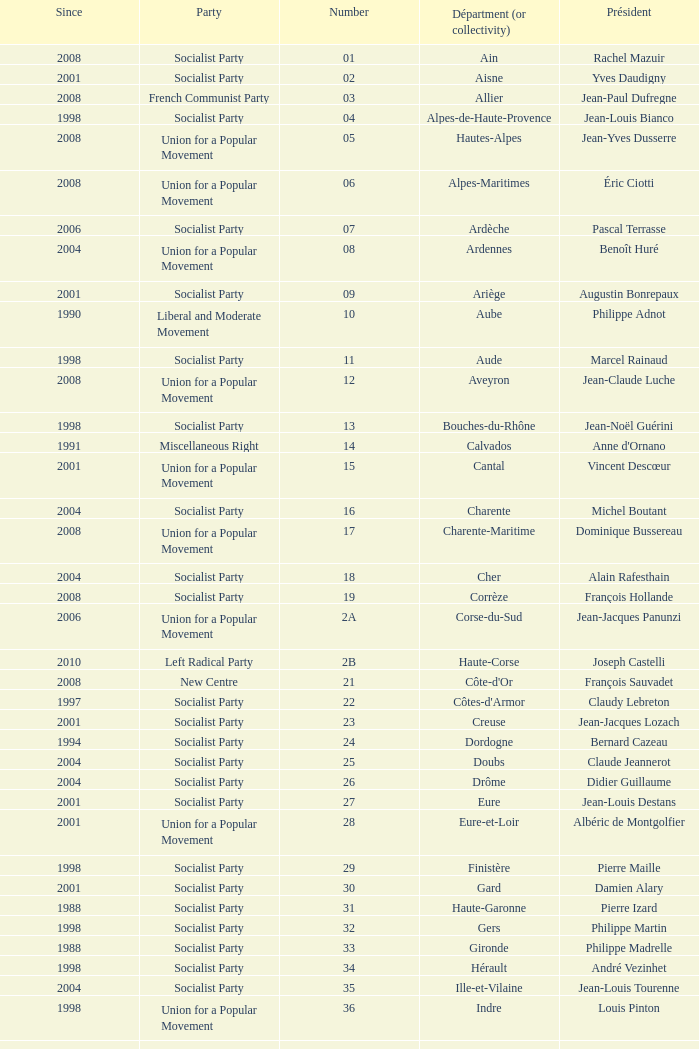Can you parse all the data within this table? {'header': ['Since', 'Party', 'Number', 'Départment (or collectivity)', 'Président'], 'rows': [['2008', 'Socialist Party', '01', 'Ain', 'Rachel Mazuir'], ['2001', 'Socialist Party', '02', 'Aisne', 'Yves Daudigny'], ['2008', 'French Communist Party', '03', 'Allier', 'Jean-Paul Dufregne'], ['1998', 'Socialist Party', '04', 'Alpes-de-Haute-Provence', 'Jean-Louis Bianco'], ['2008', 'Union for a Popular Movement', '05', 'Hautes-Alpes', 'Jean-Yves Dusserre'], ['2008', 'Union for a Popular Movement', '06', 'Alpes-Maritimes', 'Éric Ciotti'], ['2006', 'Socialist Party', '07', 'Ardèche', 'Pascal Terrasse'], ['2004', 'Union for a Popular Movement', '08', 'Ardennes', 'Benoît Huré'], ['2001', 'Socialist Party', '09', 'Ariège', 'Augustin Bonrepaux'], ['1990', 'Liberal and Moderate Movement', '10', 'Aube', 'Philippe Adnot'], ['1998', 'Socialist Party', '11', 'Aude', 'Marcel Rainaud'], ['2008', 'Union for a Popular Movement', '12', 'Aveyron', 'Jean-Claude Luche'], ['1998', 'Socialist Party', '13', 'Bouches-du-Rhône', 'Jean-Noël Guérini'], ['1991', 'Miscellaneous Right', '14', 'Calvados', "Anne d'Ornano"], ['2001', 'Union for a Popular Movement', '15', 'Cantal', 'Vincent Descœur'], ['2004', 'Socialist Party', '16', 'Charente', 'Michel Boutant'], ['2008', 'Union for a Popular Movement', '17', 'Charente-Maritime', 'Dominique Bussereau'], ['2004', 'Socialist Party', '18', 'Cher', 'Alain Rafesthain'], ['2008', 'Socialist Party', '19', 'Corrèze', 'François Hollande'], ['2006', 'Union for a Popular Movement', '2A', 'Corse-du-Sud', 'Jean-Jacques Panunzi'], ['2010', 'Left Radical Party', '2B', 'Haute-Corse', 'Joseph Castelli'], ['2008', 'New Centre', '21', "Côte-d'Or", 'François Sauvadet'], ['1997', 'Socialist Party', '22', "Côtes-d'Armor", 'Claudy Lebreton'], ['2001', 'Socialist Party', '23', 'Creuse', 'Jean-Jacques Lozach'], ['1994', 'Socialist Party', '24', 'Dordogne', 'Bernard Cazeau'], ['2004', 'Socialist Party', '25', 'Doubs', 'Claude Jeannerot'], ['2004', 'Socialist Party', '26', 'Drôme', 'Didier Guillaume'], ['2001', 'Socialist Party', '27', 'Eure', 'Jean-Louis Destans'], ['2001', 'Union for a Popular Movement', '28', 'Eure-et-Loir', 'Albéric de Montgolfier'], ['1998', 'Socialist Party', '29', 'Finistère', 'Pierre Maille'], ['2001', 'Socialist Party', '30', 'Gard', 'Damien Alary'], ['1988', 'Socialist Party', '31', 'Haute-Garonne', 'Pierre Izard'], ['1998', 'Socialist Party', '32', 'Gers', 'Philippe Martin'], ['1988', 'Socialist Party', '33', 'Gironde', 'Philippe Madrelle'], ['1998', 'Socialist Party', '34', 'Hérault', 'André Vezinhet'], ['2004', 'Socialist Party', '35', 'Ille-et-Vilaine', 'Jean-Louis Tourenne'], ['1998', 'Union for a Popular Movement', '36', 'Indre', 'Louis Pinton'], ['2008', 'Socialist Party', '37', 'Indre-et-Loire', 'Claude Roiron'], ['2001', 'Socialist Party', '38', 'Isère', 'André Vallini'], ['2008', 'Miscellaneous Right', '39', 'Jura', 'Jean Raquin'], ['1982', 'Socialist Party', '40', 'Landes', 'Henri Emmanuelli'], ['2004', 'New Centre', '41', 'Loir-et-Cher', 'Maurice Leroy'], ['2008', 'Union for a Popular Movement', '42', 'Loire', 'Bernard Bonne'], ['2004', 'Union for a Popular Movement', '43', 'Haute-Loire', 'Gérard Roche'], ['2004', 'Socialist Party', '44', 'Loire-Atlantique', 'Patrick Mareschal'], ['1994', 'Union for a Popular Movement', '45', 'Loiret', 'Éric Doligé'], ['2004', 'Socialist Party', '46', 'Lot', 'Gérard Miquel'], ['2008', 'Socialist Party', '47', 'Lot-et-Garonne', 'Pierre Camani'], ['2004', 'Union for a Popular Movement', '48', 'Lozère', 'Jean-Paul Pourquier'], ['2004', 'Union for a Popular Movement', '49', 'Maine-et-Loire', 'Christophe Béchu'], ['1998', 'Union for a Popular Movement', '50', 'Manche', 'Jean-François Le Grand'], ['2003', 'Union for a Popular Movement', '51', 'Marne', 'René-Paul Savary'], ['1998', 'Union for a Popular Movement', '52', 'Haute-Marne', 'Bruno Sido'], ['1992', 'Miscellaneous Centre', '53', 'Mayenne', 'Jean Arthuis'], ['1998', 'Socialist Party', '54', 'Meurthe-et-Moselle', 'Michel Dinet'], ['2004', 'Miscellaneous Right', '55', 'Meuse', 'Christian Namy'], ['2004', 'Democratic Movement', '56', 'Morbihan', 'Joseph-François Kerguéris'], ['1992', 'Union for a Popular Movement', '57', 'Moselle', 'Philippe Leroy'], ['2001', 'Socialist Party', '58', 'Nièvre', 'Marcel Charmant'], ['1998', 'Socialist Party', '59', 'Nord', 'Patrick Kanner'], ['2004', 'Socialist Party', '60', 'Oise', 'Yves Rome'], ['2007', 'Union for a Popular Movement', '61', 'Orne', 'Alain Lambert'], ['2004', 'Socialist Party', '62', 'Pas-de-Calais', 'Dominique Dupilet'], ['2004', 'Socialist Party', '63', 'Puy-de-Dôme', 'Jean-Yves Gouttebel'], ['2008', 'Union for a Popular Movement', '64', 'Pyrénées-Atlantiques', 'Jean Castaings'], ['2008', 'Socialist Party', '65', 'Hautes-Pyrénées', 'Josette Durrieu'], ['1998', 'Socialist Party', '66', 'Pyrénées-Orientales', 'Christian Bourquin'], ['2008', 'Union for a Popular Movement', '67', 'Bas-Rhin', 'Guy-Dominique Kennel'], ['2004', 'Union for a Popular Movement', '68', 'Haut-Rhin', 'Charles Buttner'], ['1990', 'Miscellaneous Centre', '69', 'Rhône', 'Michel Mercier'], ['2002', 'Socialist Party', '70', 'Haute-Saône', 'Yves Krattinger'], ['2008', 'Socialist Party', '71', 'Saône-et-Loire', 'Arnaud Montebourg'], ['1998', 'Union for a Popular Movement', '72', 'Sarthe', 'Roland du Luart'], ['2008', 'Union for a Popular Movement', '73', 'Savoie', 'Hervé Gaymard'], ['2008', 'Miscellaneous Right', '74', 'Haute-Savoie', 'Christian Monteil'], ['2001', 'Socialist Party', '75', 'Paris', 'Bertrand Delanoë'], ['2004', 'Socialist Party', '76', 'Seine-Maritime', 'Didier Marie'], ['2004', 'Socialist Party', '77', 'Seine-et-Marne', 'Vincent Eblé'], ['2005', 'Union for a Popular Movement', '78', 'Yvelines', 'Pierre Bédier'], ['2008', 'Socialist Party', '79', 'Deux-Sèvres', 'Éric Gautier'], ['2008', 'Socialist Party', '80', 'Somme', 'Christian Manable'], ['1991', 'Socialist Party', '81', 'Tarn', 'Thierry Carcenac'], ['1986', 'Left Radical Party', '82', 'Tarn-et-Garonne', 'Jean-Michel Baylet'], ['2002', 'Union for a Popular Movement', '83', 'Var', 'Horace Lanfranchi'], ['2001', 'Socialist Party', '84', 'Vaucluse', 'Claude Haut'], ['1988', 'Movement for France', '85', 'Vendée', 'Philippe de Villiers'], ['2008', 'Union for a Popular Movement', '86', 'Vienne', 'Claude Bertaud'], ['2004', 'Socialist Party', '87', 'Haute-Vienne', 'Marie-Françoise Pérol-Dumont'], ['1976', 'Union for a Popular Movement', '88', 'Vosges', 'Christian Poncelet'], ['2008', 'Union for a Popular Movement', '89', 'Yonne', 'Jean-Marie Rolland'], ['2004', 'Socialist Party', '90', 'Territoire de Belfort', 'Yves Ackermann'], ['1998', 'Socialist Party', '91', 'Essonne', 'Michel Berson'], ['2007', 'Union for a Popular Movement', '92', 'Hauts-de-Seine', 'Patrick Devedjian'], ['2008', 'Socialist Party', '93', 'Seine-Saint-Denis', 'Claude Bartolone'], ['2001', 'French Communist Party', '94', 'Val-de-Marne', 'Christian Favier'], ['2011', 'Union for a Popular Movement', '95', 'Val-d’Oise', 'Arnaud Bazin'], ['2001', 'United Guadeloupe, Socialism and Realities', '971', 'Guadeloupe', 'Jacques Gillot'], ['1992', 'Martinican Democratic Rally', '972', 'Martinique', 'Claude Lise'], ['2008', 'Miscellaneous Left', '973', 'Guyane', 'Alain Tien-Liong'], ['2004', 'Union for a Popular Movement', '974', 'Réunion', 'Nassimah Dindar'], ['2006', 'Archipelago Tomorrow', '975', 'Saint-Pierre-et-Miquelon (overseas collect.)', 'Stéphane Artano'], ['2008', 'Union for a Popular Movement', '976', 'Mayotte (overseas collect.)', 'Ahmed Attoumani Douchina']]} What number corresponds to Presidet Yves Krattinger of the Socialist party? 70.0. 